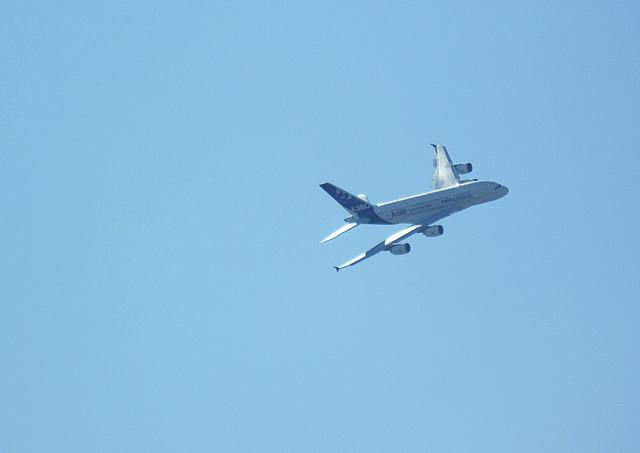Is the plane ready to land?
Give a very brief answer. No. Is the airplane crashing?
Short answer required. No. Is this a commercial airline plane?
Write a very short answer. Yes. Why is the plane slightly tilting?
Keep it brief. Turning. What mode of transportation is in the picture?
Concise answer only. Plane. What direction is the plane pointed?
Keep it brief. Right. 